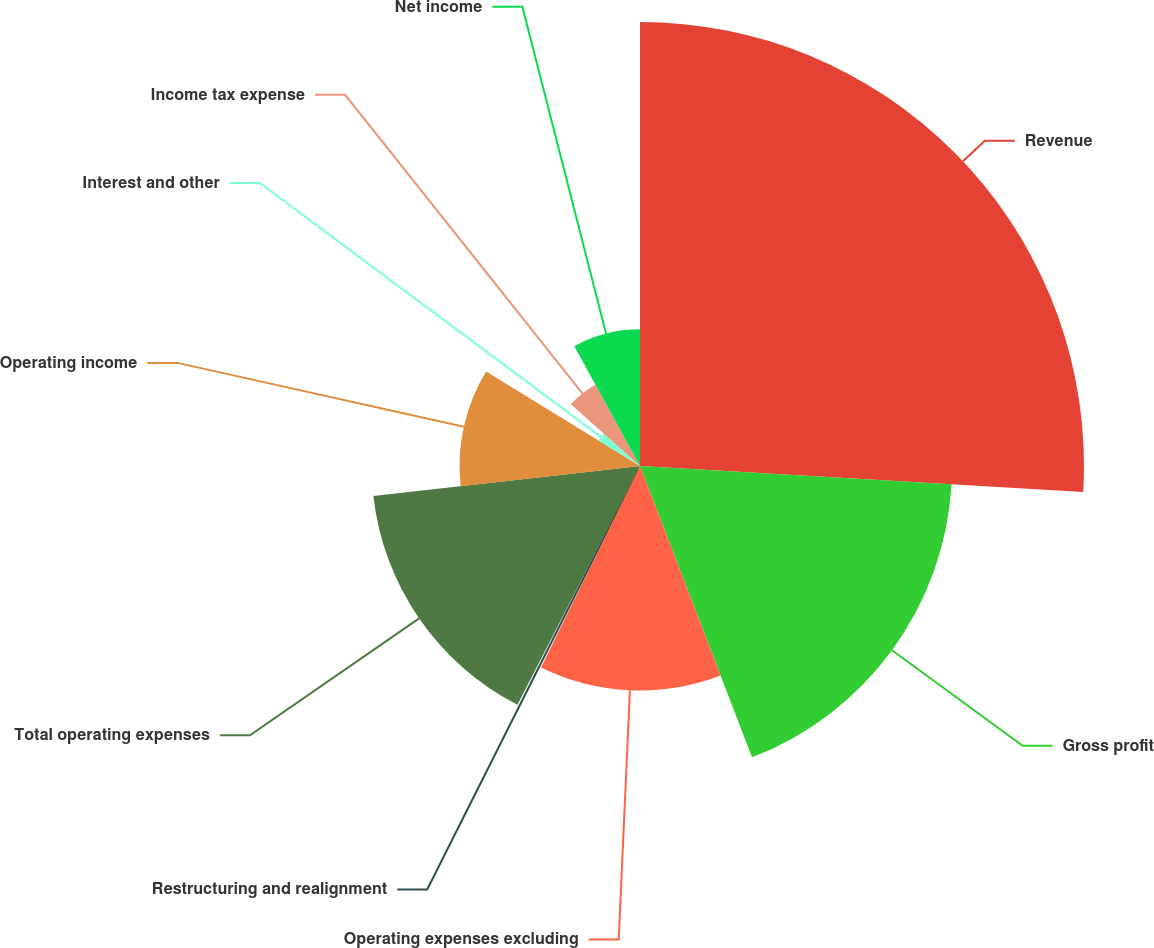Convert chart. <chart><loc_0><loc_0><loc_500><loc_500><pie_chart><fcel>Revenue<fcel>Gross profit<fcel>Operating expenses excluding<fcel>Restructuring and realignment<fcel>Total operating expenses<fcel>Operating income<fcel>Interest and other<fcel>Income tax expense<fcel>Net income<nl><fcel>25.93%<fcel>18.23%<fcel>13.11%<fcel>0.28%<fcel>15.67%<fcel>10.54%<fcel>2.85%<fcel>5.41%<fcel>7.98%<nl></chart> 